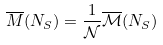<formula> <loc_0><loc_0><loc_500><loc_500>\overline { M } ( N _ { S } ) = \frac { 1 } { \mathcal { N } } \overline { \mathcal { M } } ( N _ { S } )</formula> 